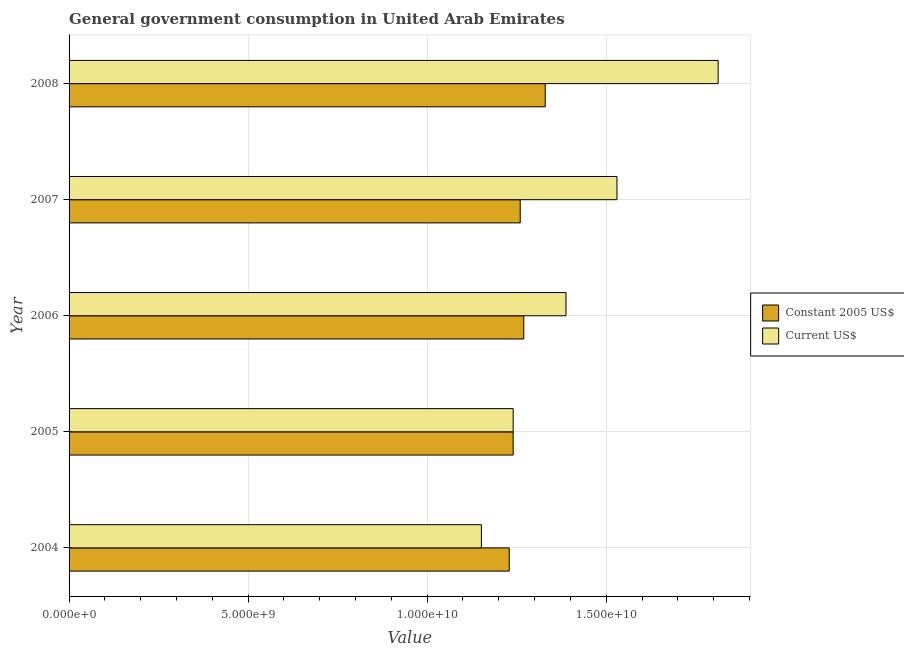How many groups of bars are there?
Keep it short and to the point. 5. Are the number of bars per tick equal to the number of legend labels?
Provide a succinct answer. Yes. How many bars are there on the 3rd tick from the top?
Your answer should be very brief. 2. How many bars are there on the 4th tick from the bottom?
Provide a succinct answer. 2. What is the label of the 4th group of bars from the top?
Your response must be concise. 2005. What is the value consumed in current us$ in 2004?
Your answer should be compact. 1.15e+1. Across all years, what is the maximum value consumed in current us$?
Provide a succinct answer. 1.81e+1. Across all years, what is the minimum value consumed in constant 2005 us$?
Keep it short and to the point. 1.23e+1. In which year was the value consumed in constant 2005 us$ maximum?
Your answer should be very brief. 2008. In which year was the value consumed in current us$ minimum?
Ensure brevity in your answer.  2004. What is the total value consumed in current us$ in the graph?
Ensure brevity in your answer.  7.12e+1. What is the difference between the value consumed in constant 2005 us$ in 2005 and that in 2006?
Keep it short and to the point. -2.96e+08. What is the difference between the value consumed in constant 2005 us$ in 2008 and the value consumed in current us$ in 2006?
Provide a short and direct response. -5.79e+08. What is the average value consumed in current us$ per year?
Your answer should be very brief. 1.42e+1. In the year 2004, what is the difference between the value consumed in current us$ and value consumed in constant 2005 us$?
Provide a succinct answer. -7.78e+08. In how many years, is the value consumed in current us$ greater than 10000000000 ?
Provide a succinct answer. 5. What is the ratio of the value consumed in current us$ in 2005 to that in 2007?
Ensure brevity in your answer.  0.81. What is the difference between the highest and the second highest value consumed in constant 2005 us$?
Give a very brief answer. 5.99e+08. What is the difference between the highest and the lowest value consumed in constant 2005 us$?
Your response must be concise. 1.00e+09. In how many years, is the value consumed in current us$ greater than the average value consumed in current us$ taken over all years?
Keep it short and to the point. 2. Is the sum of the value consumed in constant 2005 us$ in 2005 and 2007 greater than the maximum value consumed in current us$ across all years?
Keep it short and to the point. Yes. What does the 2nd bar from the top in 2006 represents?
Provide a succinct answer. Constant 2005 US$. What does the 2nd bar from the bottom in 2008 represents?
Offer a very short reply. Current US$. How many bars are there?
Your answer should be compact. 10. Are all the bars in the graph horizontal?
Offer a terse response. Yes. How many years are there in the graph?
Your answer should be compact. 5. What is the difference between two consecutive major ticks on the X-axis?
Offer a terse response. 5.00e+09. Where does the legend appear in the graph?
Offer a terse response. Center right. What is the title of the graph?
Your answer should be very brief. General government consumption in United Arab Emirates. What is the label or title of the X-axis?
Ensure brevity in your answer.  Value. What is the label or title of the Y-axis?
Offer a terse response. Year. What is the Value in Constant 2005 US$ in 2004?
Give a very brief answer. 1.23e+1. What is the Value in Current US$ in 2004?
Your answer should be compact. 1.15e+1. What is the Value in Constant 2005 US$ in 2005?
Make the answer very short. 1.24e+1. What is the Value of Current US$ in 2005?
Make the answer very short. 1.24e+1. What is the Value of Constant 2005 US$ in 2006?
Provide a short and direct response. 1.27e+1. What is the Value in Current US$ in 2006?
Ensure brevity in your answer.  1.39e+1. What is the Value of Constant 2005 US$ in 2007?
Ensure brevity in your answer.  1.26e+1. What is the Value in Current US$ in 2007?
Offer a very short reply. 1.53e+1. What is the Value of Constant 2005 US$ in 2008?
Your answer should be very brief. 1.33e+1. What is the Value of Current US$ in 2008?
Offer a terse response. 1.81e+1. Across all years, what is the maximum Value in Constant 2005 US$?
Make the answer very short. 1.33e+1. Across all years, what is the maximum Value in Current US$?
Ensure brevity in your answer.  1.81e+1. Across all years, what is the minimum Value in Constant 2005 US$?
Make the answer very short. 1.23e+1. Across all years, what is the minimum Value of Current US$?
Your answer should be compact. 1.15e+1. What is the total Value of Constant 2005 US$ in the graph?
Make the answer very short. 6.33e+1. What is the total Value of Current US$ in the graph?
Offer a terse response. 7.12e+1. What is the difference between the Value of Constant 2005 US$ in 2004 and that in 2005?
Offer a terse response. -1.09e+08. What is the difference between the Value in Current US$ in 2004 and that in 2005?
Offer a very short reply. -8.87e+08. What is the difference between the Value in Constant 2005 US$ in 2004 and that in 2006?
Provide a short and direct response. -4.06e+08. What is the difference between the Value in Current US$ in 2004 and that in 2006?
Keep it short and to the point. -2.36e+09. What is the difference between the Value in Constant 2005 US$ in 2004 and that in 2007?
Make the answer very short. -3.06e+08. What is the difference between the Value of Current US$ in 2004 and that in 2007?
Your answer should be very brief. -3.79e+09. What is the difference between the Value in Constant 2005 US$ in 2004 and that in 2008?
Make the answer very short. -1.00e+09. What is the difference between the Value in Current US$ in 2004 and that in 2008?
Ensure brevity in your answer.  -6.61e+09. What is the difference between the Value in Constant 2005 US$ in 2005 and that in 2006?
Ensure brevity in your answer.  -2.96e+08. What is the difference between the Value of Current US$ in 2005 and that in 2006?
Make the answer very short. -1.48e+09. What is the difference between the Value of Constant 2005 US$ in 2005 and that in 2007?
Provide a succinct answer. -1.97e+08. What is the difference between the Value of Current US$ in 2005 and that in 2007?
Give a very brief answer. -2.90e+09. What is the difference between the Value of Constant 2005 US$ in 2005 and that in 2008?
Make the answer very short. -8.96e+08. What is the difference between the Value of Current US$ in 2005 and that in 2008?
Keep it short and to the point. -5.73e+09. What is the difference between the Value of Constant 2005 US$ in 2006 and that in 2007?
Your answer should be very brief. 9.91e+07. What is the difference between the Value in Current US$ in 2006 and that in 2007?
Make the answer very short. -1.42e+09. What is the difference between the Value of Constant 2005 US$ in 2006 and that in 2008?
Offer a very short reply. -5.99e+08. What is the difference between the Value in Current US$ in 2006 and that in 2008?
Your answer should be very brief. -4.25e+09. What is the difference between the Value of Constant 2005 US$ in 2007 and that in 2008?
Offer a terse response. -6.98e+08. What is the difference between the Value of Current US$ in 2007 and that in 2008?
Make the answer very short. -2.83e+09. What is the difference between the Value in Constant 2005 US$ in 2004 and the Value in Current US$ in 2005?
Give a very brief answer. -1.09e+08. What is the difference between the Value in Constant 2005 US$ in 2004 and the Value in Current US$ in 2006?
Make the answer very short. -1.58e+09. What is the difference between the Value in Constant 2005 US$ in 2004 and the Value in Current US$ in 2007?
Offer a terse response. -3.01e+09. What is the difference between the Value of Constant 2005 US$ in 2004 and the Value of Current US$ in 2008?
Your answer should be very brief. -5.83e+09. What is the difference between the Value in Constant 2005 US$ in 2005 and the Value in Current US$ in 2006?
Your answer should be very brief. -1.48e+09. What is the difference between the Value in Constant 2005 US$ in 2005 and the Value in Current US$ in 2007?
Offer a very short reply. -2.90e+09. What is the difference between the Value in Constant 2005 US$ in 2005 and the Value in Current US$ in 2008?
Keep it short and to the point. -5.73e+09. What is the difference between the Value in Constant 2005 US$ in 2006 and the Value in Current US$ in 2007?
Give a very brief answer. -2.60e+09. What is the difference between the Value in Constant 2005 US$ in 2006 and the Value in Current US$ in 2008?
Provide a short and direct response. -5.43e+09. What is the difference between the Value in Constant 2005 US$ in 2007 and the Value in Current US$ in 2008?
Your answer should be very brief. -5.53e+09. What is the average Value of Constant 2005 US$ per year?
Offer a very short reply. 1.27e+1. What is the average Value in Current US$ per year?
Provide a short and direct response. 1.42e+1. In the year 2004, what is the difference between the Value in Constant 2005 US$ and Value in Current US$?
Give a very brief answer. 7.78e+08. In the year 2006, what is the difference between the Value in Constant 2005 US$ and Value in Current US$?
Your answer should be very brief. -1.18e+09. In the year 2007, what is the difference between the Value in Constant 2005 US$ and Value in Current US$?
Give a very brief answer. -2.70e+09. In the year 2008, what is the difference between the Value of Constant 2005 US$ and Value of Current US$?
Provide a short and direct response. -4.83e+09. What is the ratio of the Value in Constant 2005 US$ in 2004 to that in 2005?
Offer a very short reply. 0.99. What is the ratio of the Value in Current US$ in 2004 to that in 2005?
Provide a succinct answer. 0.93. What is the ratio of the Value of Constant 2005 US$ in 2004 to that in 2006?
Offer a very short reply. 0.97. What is the ratio of the Value of Current US$ in 2004 to that in 2006?
Provide a short and direct response. 0.83. What is the ratio of the Value in Constant 2005 US$ in 2004 to that in 2007?
Make the answer very short. 0.98. What is the ratio of the Value in Current US$ in 2004 to that in 2007?
Ensure brevity in your answer.  0.75. What is the ratio of the Value of Constant 2005 US$ in 2004 to that in 2008?
Keep it short and to the point. 0.92. What is the ratio of the Value in Current US$ in 2004 to that in 2008?
Give a very brief answer. 0.64. What is the ratio of the Value in Constant 2005 US$ in 2005 to that in 2006?
Offer a very short reply. 0.98. What is the ratio of the Value in Current US$ in 2005 to that in 2006?
Provide a short and direct response. 0.89. What is the ratio of the Value of Constant 2005 US$ in 2005 to that in 2007?
Give a very brief answer. 0.98. What is the ratio of the Value of Current US$ in 2005 to that in 2007?
Your response must be concise. 0.81. What is the ratio of the Value in Constant 2005 US$ in 2005 to that in 2008?
Provide a short and direct response. 0.93. What is the ratio of the Value in Current US$ in 2005 to that in 2008?
Keep it short and to the point. 0.68. What is the ratio of the Value of Constant 2005 US$ in 2006 to that in 2007?
Your response must be concise. 1.01. What is the ratio of the Value in Current US$ in 2006 to that in 2007?
Offer a terse response. 0.91. What is the ratio of the Value of Constant 2005 US$ in 2006 to that in 2008?
Your answer should be compact. 0.95. What is the ratio of the Value of Current US$ in 2006 to that in 2008?
Give a very brief answer. 0.77. What is the ratio of the Value of Constant 2005 US$ in 2007 to that in 2008?
Keep it short and to the point. 0.95. What is the ratio of the Value of Current US$ in 2007 to that in 2008?
Make the answer very short. 0.84. What is the difference between the highest and the second highest Value in Constant 2005 US$?
Keep it short and to the point. 5.99e+08. What is the difference between the highest and the second highest Value in Current US$?
Provide a succinct answer. 2.83e+09. What is the difference between the highest and the lowest Value in Constant 2005 US$?
Make the answer very short. 1.00e+09. What is the difference between the highest and the lowest Value in Current US$?
Your answer should be very brief. 6.61e+09. 